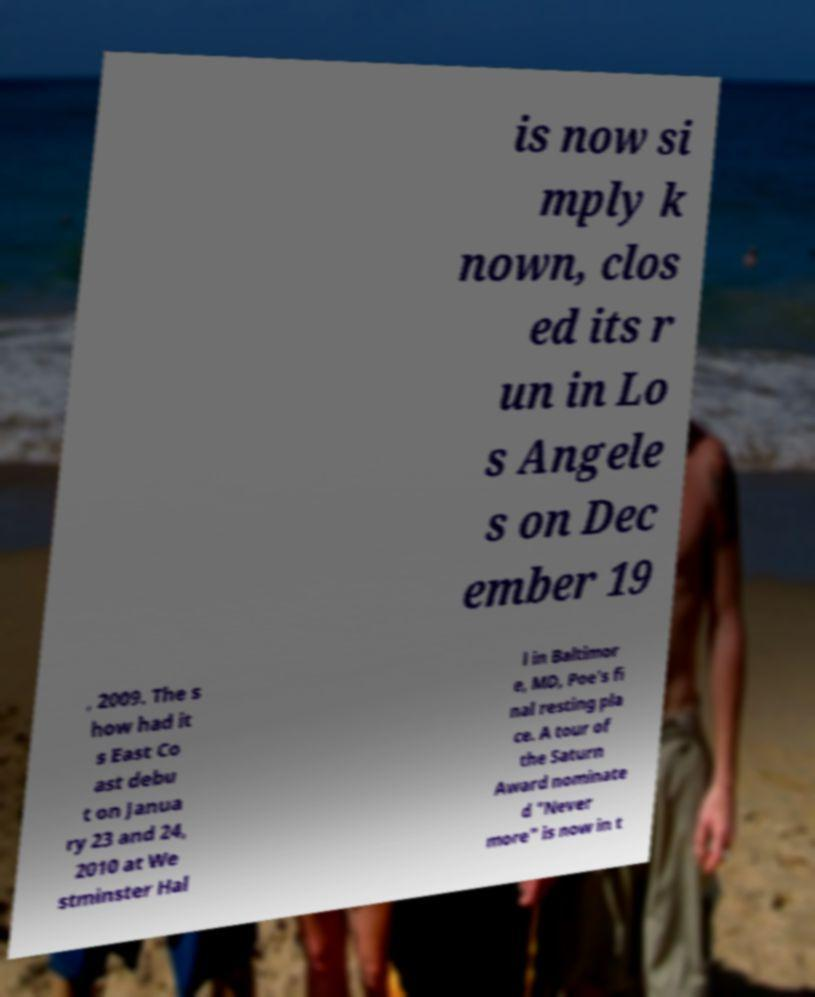Please identify and transcribe the text found in this image. is now si mply k nown, clos ed its r un in Lo s Angele s on Dec ember 19 , 2009. The s how had it s East Co ast debu t on Janua ry 23 and 24, 2010 at We stminster Hal l in Baltimor e, MD, Poe's fi nal resting pla ce. A tour of the Saturn Award nominate d "Never more" is now in t 